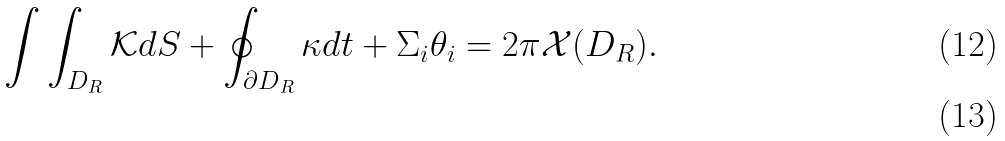<formula> <loc_0><loc_0><loc_500><loc_500>\int \int _ { { D } _ { R } } \mathcal { K } d S + \oint _ { { \partial D } _ { R } } \kappa d t + \Sigma _ { i } \theta _ { i } = 2 \pi \mathcal { X } ( D _ { R } ) . \\</formula> 